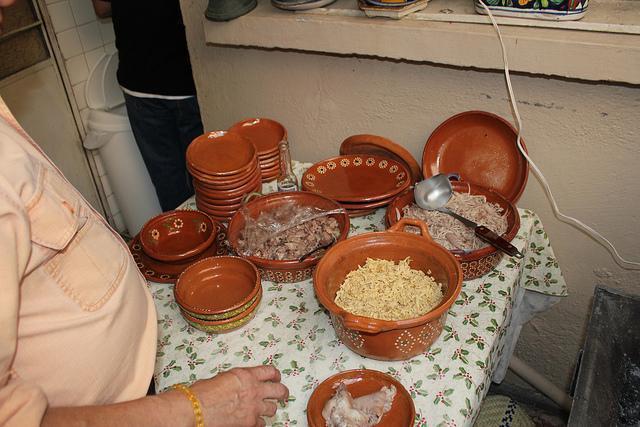How many bowls have food in them?
Give a very brief answer. 4. How many people are in the photo?
Give a very brief answer. 2. How many bowls are there?
Give a very brief answer. 6. How many bus on the road?
Give a very brief answer. 0. 